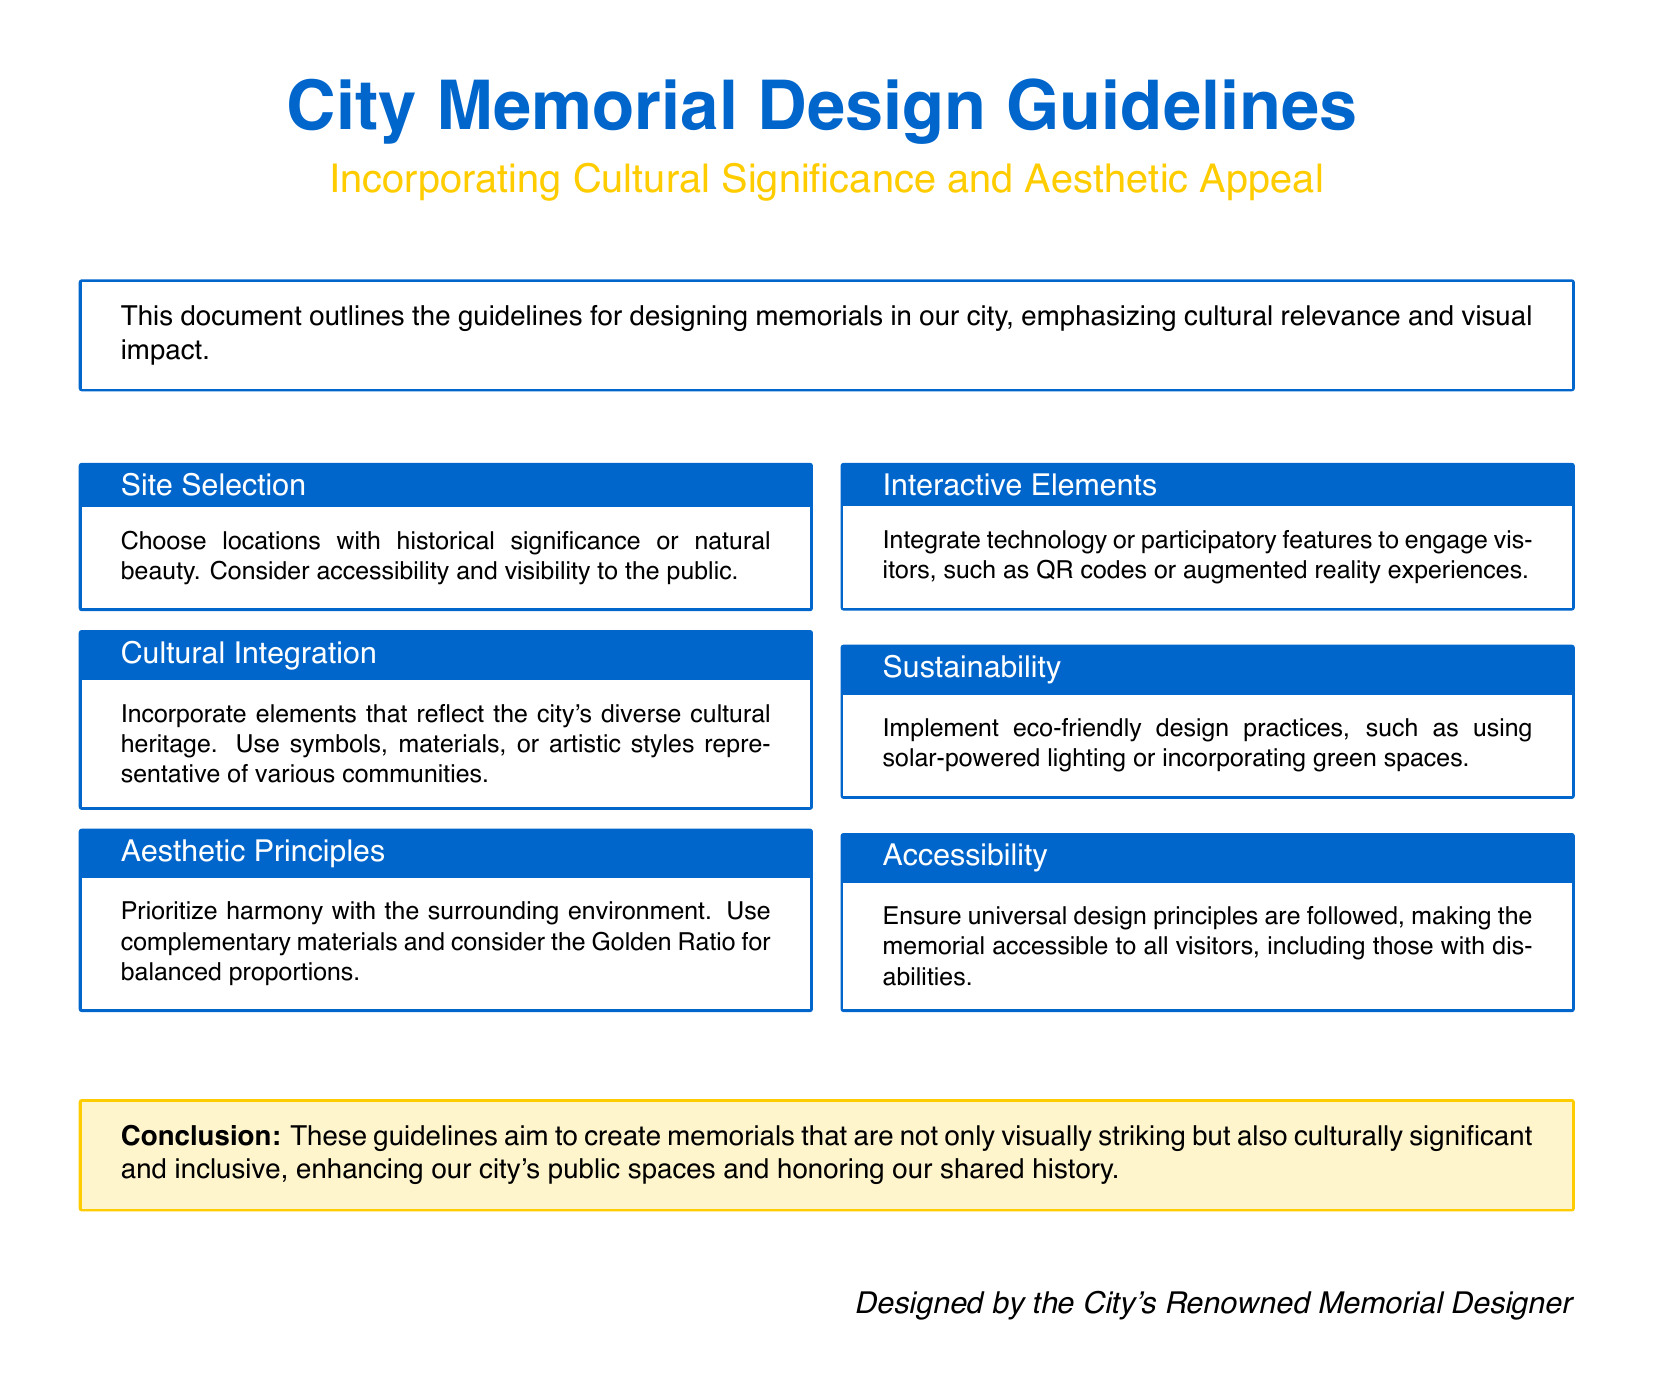what is the main focus of the City Memorial Design Guidelines? The document emphasizes the importance of cultural relevance and visual impact in memorial designs.
Answer: cultural relevance and visual impact what considerations should be made for site selection? The guidelines suggest considering historical significance, natural beauty, accessibility, and visibility.
Answer: historical significance, natural beauty, accessibility, visibility what aesthetic principle is prioritized in the design? The memorial designs should emphasize harmony with the surrounding environment.
Answer: harmony with the surrounding environment what interactive feature is suggested for visitors? The guidelines recommend integrating technology like QR codes or augmented reality experiences.
Answer: QR codes or augmented reality experiences what material consideration is mentioned for cultural integration? The document suggests using materials that are representative of various communities.
Answer: materials representative of various communities how should the memorials ensure accessibility? The guidelines state that universal design principles should be followed.
Answer: universal design principles what type of design practices should be implemented for sustainability? The document encourages using eco-friendly design practices, such as solar-powered lighting.
Answer: eco-friendly design practices who designed the guidelines? The document credits the design to the City's Renowned Memorial Designer.
Answer: City's Renowned Memorial Designer what is the significance of the Golden Ratio in the design? The guidelines mention considering the Golden Ratio for balanced proportions in memorials.
Answer: balanced proportions 